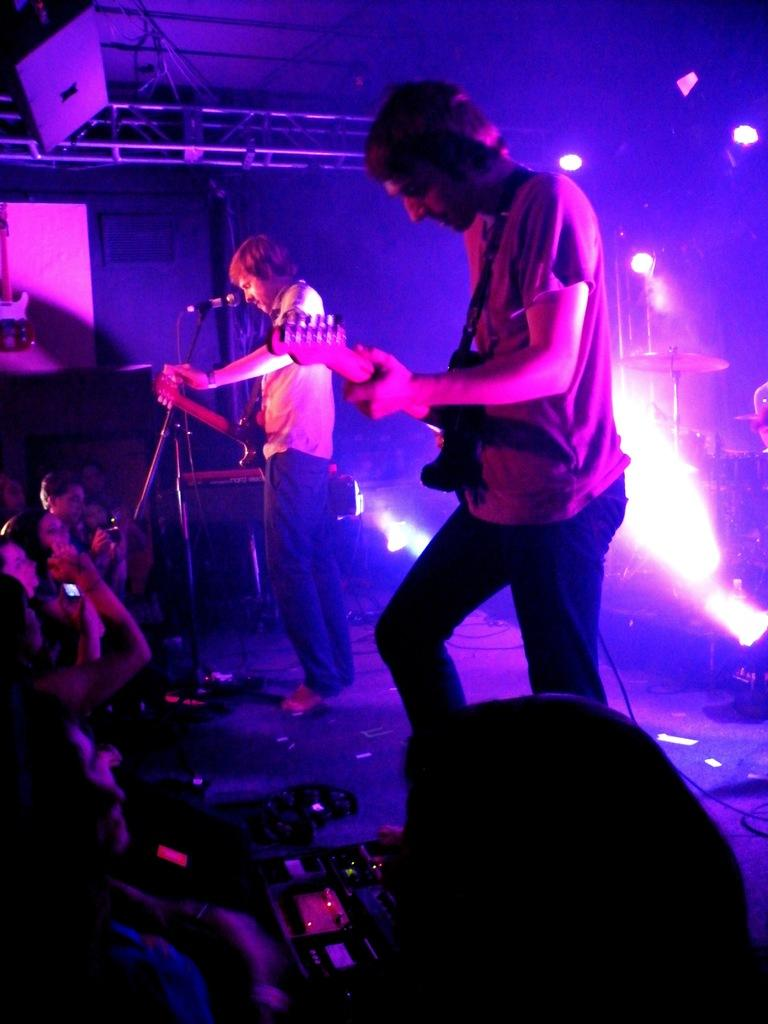How many people are in the image? There are two persons in the image. What are the persons doing in the image? The persons are standing and playing a guitar. Can you describe the presence of a microphone in the image? There is a microphone in front of one of the persons. What other objects related to music can be seen in the image? There are musical instruments in the image. What type of lighting is visible in the image? There are focusing lights visible in the image. Who else is present in the image besides the two persons playing the guitar? There are people (audience) in the image. Can you tell me the name of the song being played by the ghost in the image? There is no ghost present in the image, and therefore no song can be attributed to a ghost. 